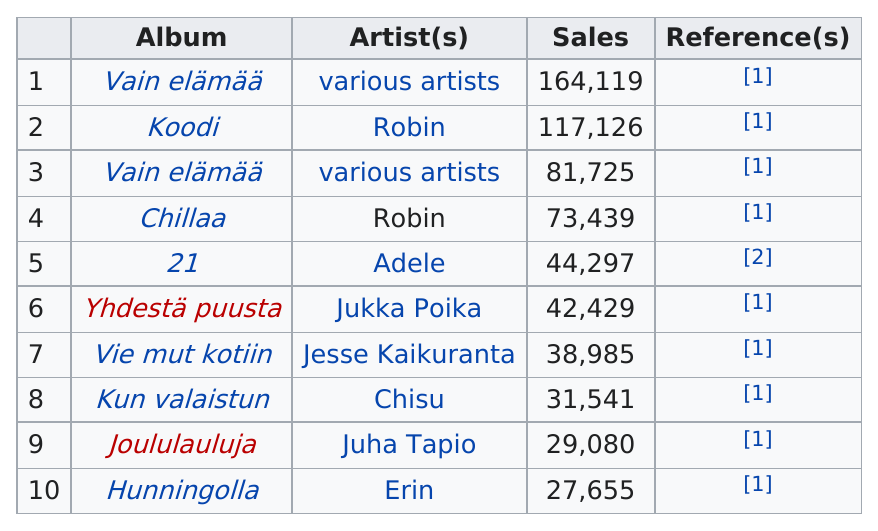Draw attention to some important aspects in this diagram. The album that is listed before 21 is 20. Adele's album had 44,297 sales this year. Vain elämää is the album with the highest number of sales that does not have a designated artist. The singer Adele has sold more albums than Chisu. Both Hunningolla and Vain elämää were successful in sales, but Vain elämää outsold Hunningolla. 